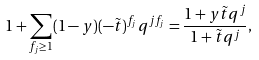<formula> <loc_0><loc_0><loc_500><loc_500>1 + \sum _ { f _ { j } \geq 1 } ( 1 - y ) ( - \tilde { t } ) ^ { f _ { j } } q ^ { j f _ { j } } = \frac { 1 + y \tilde { t } q ^ { j } } { 1 + \tilde { t } q ^ { j } } ,</formula> 